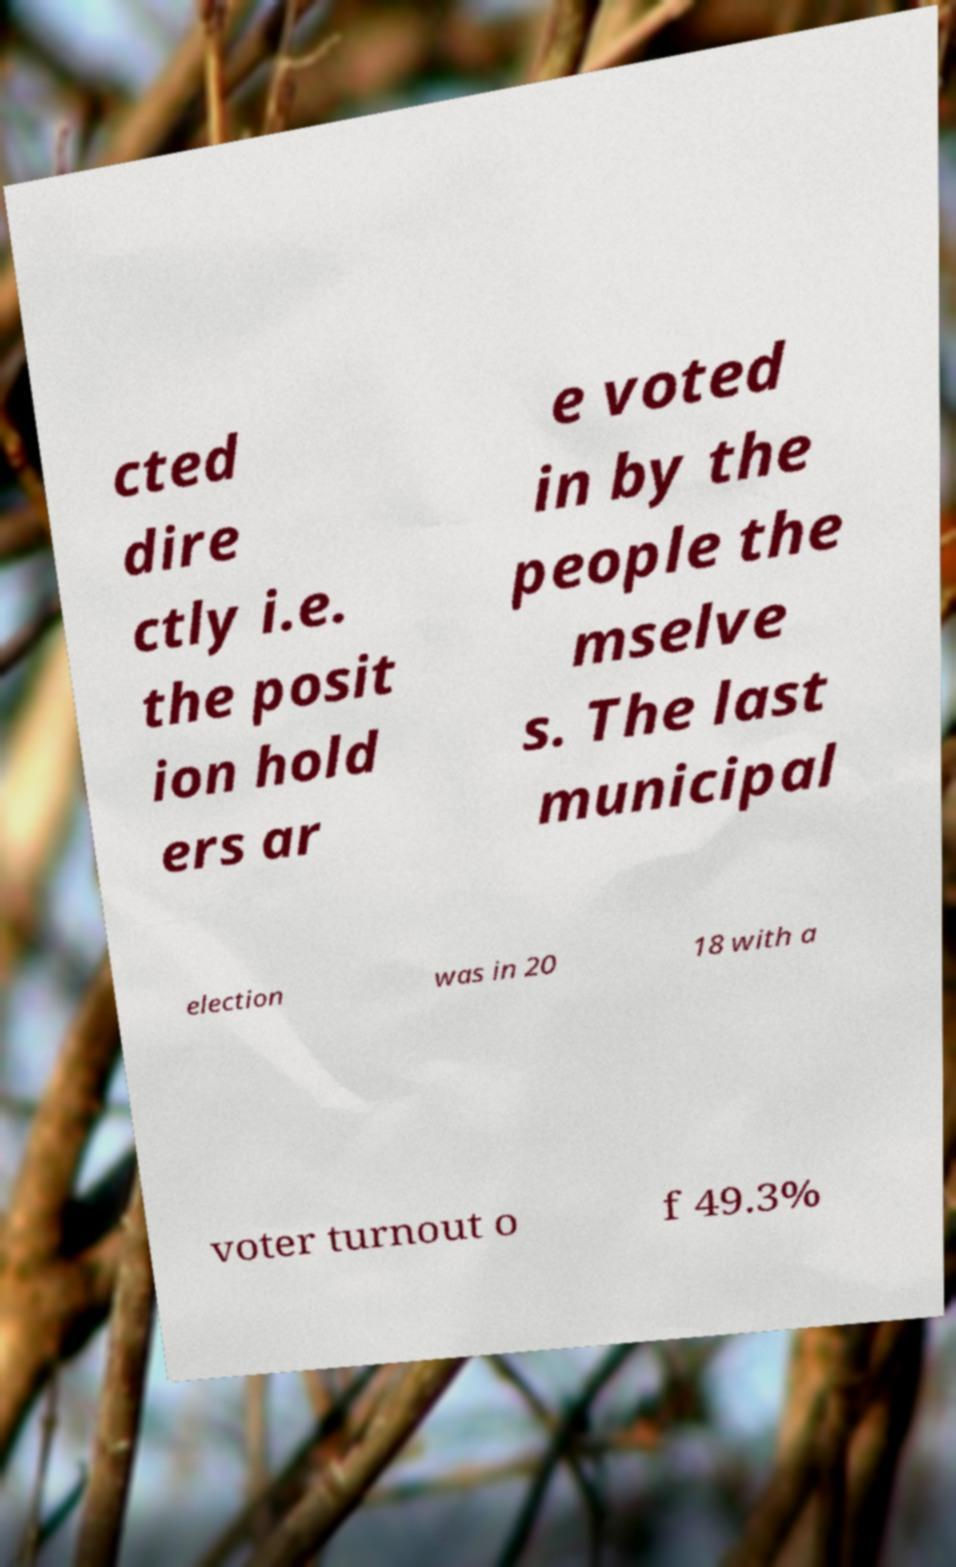Please identify and transcribe the text found in this image. cted dire ctly i.e. the posit ion hold ers ar e voted in by the people the mselve s. The last municipal election was in 20 18 with a voter turnout o f 49.3% 